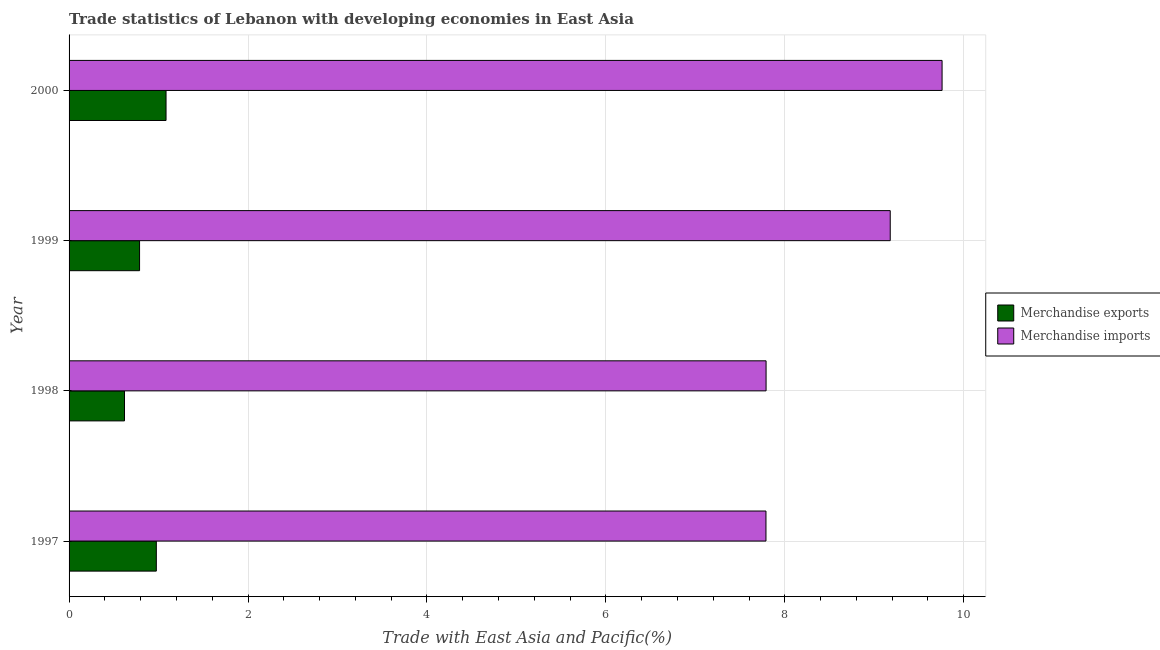How many groups of bars are there?
Provide a short and direct response. 4. Are the number of bars per tick equal to the number of legend labels?
Provide a short and direct response. Yes. Are the number of bars on each tick of the Y-axis equal?
Your answer should be very brief. Yes. How many bars are there on the 3rd tick from the top?
Give a very brief answer. 2. What is the merchandise imports in 1999?
Keep it short and to the point. 9.18. Across all years, what is the maximum merchandise exports?
Your answer should be very brief. 1.08. Across all years, what is the minimum merchandise exports?
Provide a short and direct response. 0.62. In which year was the merchandise exports maximum?
Give a very brief answer. 2000. What is the total merchandise imports in the graph?
Provide a short and direct response. 34.51. What is the difference between the merchandise exports in 1997 and that in 1998?
Ensure brevity in your answer.  0.36. What is the difference between the merchandise imports in 1998 and the merchandise exports in 1997?
Provide a succinct answer. 6.82. What is the average merchandise imports per year?
Offer a terse response. 8.63. In the year 1999, what is the difference between the merchandise imports and merchandise exports?
Your response must be concise. 8.39. In how many years, is the merchandise exports greater than 1.2000000000000002 %?
Keep it short and to the point. 0. Is the difference between the merchandise imports in 1997 and 2000 greater than the difference between the merchandise exports in 1997 and 2000?
Make the answer very short. No. What is the difference between the highest and the second highest merchandise exports?
Your answer should be very brief. 0.11. What is the difference between the highest and the lowest merchandise exports?
Your answer should be compact. 0.46. In how many years, is the merchandise imports greater than the average merchandise imports taken over all years?
Ensure brevity in your answer.  2. Is the sum of the merchandise imports in 1999 and 2000 greater than the maximum merchandise exports across all years?
Provide a short and direct response. Yes. What does the 2nd bar from the bottom in 2000 represents?
Provide a short and direct response. Merchandise imports. How many bars are there?
Provide a succinct answer. 8. Are all the bars in the graph horizontal?
Offer a terse response. Yes. How many years are there in the graph?
Give a very brief answer. 4. Does the graph contain grids?
Keep it short and to the point. Yes. What is the title of the graph?
Provide a succinct answer. Trade statistics of Lebanon with developing economies in East Asia. What is the label or title of the X-axis?
Ensure brevity in your answer.  Trade with East Asia and Pacific(%). What is the label or title of the Y-axis?
Offer a terse response. Year. What is the Trade with East Asia and Pacific(%) of Merchandise exports in 1997?
Your response must be concise. 0.98. What is the Trade with East Asia and Pacific(%) of Merchandise imports in 1997?
Your answer should be compact. 7.79. What is the Trade with East Asia and Pacific(%) of Merchandise exports in 1998?
Make the answer very short. 0.62. What is the Trade with East Asia and Pacific(%) in Merchandise imports in 1998?
Give a very brief answer. 7.79. What is the Trade with East Asia and Pacific(%) in Merchandise exports in 1999?
Give a very brief answer. 0.79. What is the Trade with East Asia and Pacific(%) in Merchandise imports in 1999?
Your answer should be compact. 9.18. What is the Trade with East Asia and Pacific(%) of Merchandise exports in 2000?
Make the answer very short. 1.08. What is the Trade with East Asia and Pacific(%) of Merchandise imports in 2000?
Make the answer very short. 9.76. Across all years, what is the maximum Trade with East Asia and Pacific(%) of Merchandise exports?
Your answer should be very brief. 1.08. Across all years, what is the maximum Trade with East Asia and Pacific(%) in Merchandise imports?
Provide a short and direct response. 9.76. Across all years, what is the minimum Trade with East Asia and Pacific(%) in Merchandise exports?
Offer a terse response. 0.62. Across all years, what is the minimum Trade with East Asia and Pacific(%) of Merchandise imports?
Offer a terse response. 7.79. What is the total Trade with East Asia and Pacific(%) in Merchandise exports in the graph?
Your answer should be very brief. 3.47. What is the total Trade with East Asia and Pacific(%) in Merchandise imports in the graph?
Give a very brief answer. 34.52. What is the difference between the Trade with East Asia and Pacific(%) of Merchandise exports in 1997 and that in 1998?
Your response must be concise. 0.36. What is the difference between the Trade with East Asia and Pacific(%) in Merchandise imports in 1997 and that in 1998?
Give a very brief answer. -0. What is the difference between the Trade with East Asia and Pacific(%) in Merchandise exports in 1997 and that in 1999?
Your answer should be very brief. 0.19. What is the difference between the Trade with East Asia and Pacific(%) of Merchandise imports in 1997 and that in 1999?
Ensure brevity in your answer.  -1.39. What is the difference between the Trade with East Asia and Pacific(%) of Merchandise exports in 1997 and that in 2000?
Offer a terse response. -0.11. What is the difference between the Trade with East Asia and Pacific(%) of Merchandise imports in 1997 and that in 2000?
Provide a short and direct response. -1.97. What is the difference between the Trade with East Asia and Pacific(%) of Merchandise exports in 1998 and that in 1999?
Make the answer very short. -0.17. What is the difference between the Trade with East Asia and Pacific(%) in Merchandise imports in 1998 and that in 1999?
Give a very brief answer. -1.39. What is the difference between the Trade with East Asia and Pacific(%) of Merchandise exports in 1998 and that in 2000?
Your response must be concise. -0.46. What is the difference between the Trade with East Asia and Pacific(%) in Merchandise imports in 1998 and that in 2000?
Offer a very short reply. -1.97. What is the difference between the Trade with East Asia and Pacific(%) in Merchandise exports in 1999 and that in 2000?
Make the answer very short. -0.3. What is the difference between the Trade with East Asia and Pacific(%) of Merchandise imports in 1999 and that in 2000?
Ensure brevity in your answer.  -0.58. What is the difference between the Trade with East Asia and Pacific(%) of Merchandise exports in 1997 and the Trade with East Asia and Pacific(%) of Merchandise imports in 1998?
Offer a very short reply. -6.82. What is the difference between the Trade with East Asia and Pacific(%) in Merchandise exports in 1997 and the Trade with East Asia and Pacific(%) in Merchandise imports in 1999?
Make the answer very short. -8.2. What is the difference between the Trade with East Asia and Pacific(%) in Merchandise exports in 1997 and the Trade with East Asia and Pacific(%) in Merchandise imports in 2000?
Your answer should be very brief. -8.78. What is the difference between the Trade with East Asia and Pacific(%) in Merchandise exports in 1998 and the Trade with East Asia and Pacific(%) in Merchandise imports in 1999?
Ensure brevity in your answer.  -8.56. What is the difference between the Trade with East Asia and Pacific(%) in Merchandise exports in 1998 and the Trade with East Asia and Pacific(%) in Merchandise imports in 2000?
Provide a short and direct response. -9.14. What is the difference between the Trade with East Asia and Pacific(%) of Merchandise exports in 1999 and the Trade with East Asia and Pacific(%) of Merchandise imports in 2000?
Give a very brief answer. -8.97. What is the average Trade with East Asia and Pacific(%) of Merchandise exports per year?
Provide a short and direct response. 0.87. What is the average Trade with East Asia and Pacific(%) of Merchandise imports per year?
Your answer should be very brief. 8.63. In the year 1997, what is the difference between the Trade with East Asia and Pacific(%) in Merchandise exports and Trade with East Asia and Pacific(%) in Merchandise imports?
Your response must be concise. -6.81. In the year 1998, what is the difference between the Trade with East Asia and Pacific(%) of Merchandise exports and Trade with East Asia and Pacific(%) of Merchandise imports?
Offer a terse response. -7.17. In the year 1999, what is the difference between the Trade with East Asia and Pacific(%) in Merchandise exports and Trade with East Asia and Pacific(%) in Merchandise imports?
Keep it short and to the point. -8.39. In the year 2000, what is the difference between the Trade with East Asia and Pacific(%) in Merchandise exports and Trade with East Asia and Pacific(%) in Merchandise imports?
Offer a terse response. -8.67. What is the ratio of the Trade with East Asia and Pacific(%) in Merchandise exports in 1997 to that in 1998?
Provide a short and direct response. 1.57. What is the ratio of the Trade with East Asia and Pacific(%) in Merchandise imports in 1997 to that in 1998?
Make the answer very short. 1. What is the ratio of the Trade with East Asia and Pacific(%) in Merchandise exports in 1997 to that in 1999?
Provide a short and direct response. 1.24. What is the ratio of the Trade with East Asia and Pacific(%) of Merchandise imports in 1997 to that in 1999?
Your answer should be compact. 0.85. What is the ratio of the Trade with East Asia and Pacific(%) in Merchandise exports in 1997 to that in 2000?
Provide a succinct answer. 0.9. What is the ratio of the Trade with East Asia and Pacific(%) in Merchandise imports in 1997 to that in 2000?
Offer a terse response. 0.8. What is the ratio of the Trade with East Asia and Pacific(%) of Merchandise exports in 1998 to that in 1999?
Your answer should be very brief. 0.79. What is the ratio of the Trade with East Asia and Pacific(%) of Merchandise imports in 1998 to that in 1999?
Make the answer very short. 0.85. What is the ratio of the Trade with East Asia and Pacific(%) of Merchandise exports in 1998 to that in 2000?
Your answer should be very brief. 0.57. What is the ratio of the Trade with East Asia and Pacific(%) in Merchandise imports in 1998 to that in 2000?
Your response must be concise. 0.8. What is the ratio of the Trade with East Asia and Pacific(%) of Merchandise exports in 1999 to that in 2000?
Provide a short and direct response. 0.73. What is the ratio of the Trade with East Asia and Pacific(%) of Merchandise imports in 1999 to that in 2000?
Make the answer very short. 0.94. What is the difference between the highest and the second highest Trade with East Asia and Pacific(%) of Merchandise exports?
Keep it short and to the point. 0.11. What is the difference between the highest and the second highest Trade with East Asia and Pacific(%) of Merchandise imports?
Offer a terse response. 0.58. What is the difference between the highest and the lowest Trade with East Asia and Pacific(%) in Merchandise exports?
Give a very brief answer. 0.46. What is the difference between the highest and the lowest Trade with East Asia and Pacific(%) of Merchandise imports?
Ensure brevity in your answer.  1.97. 